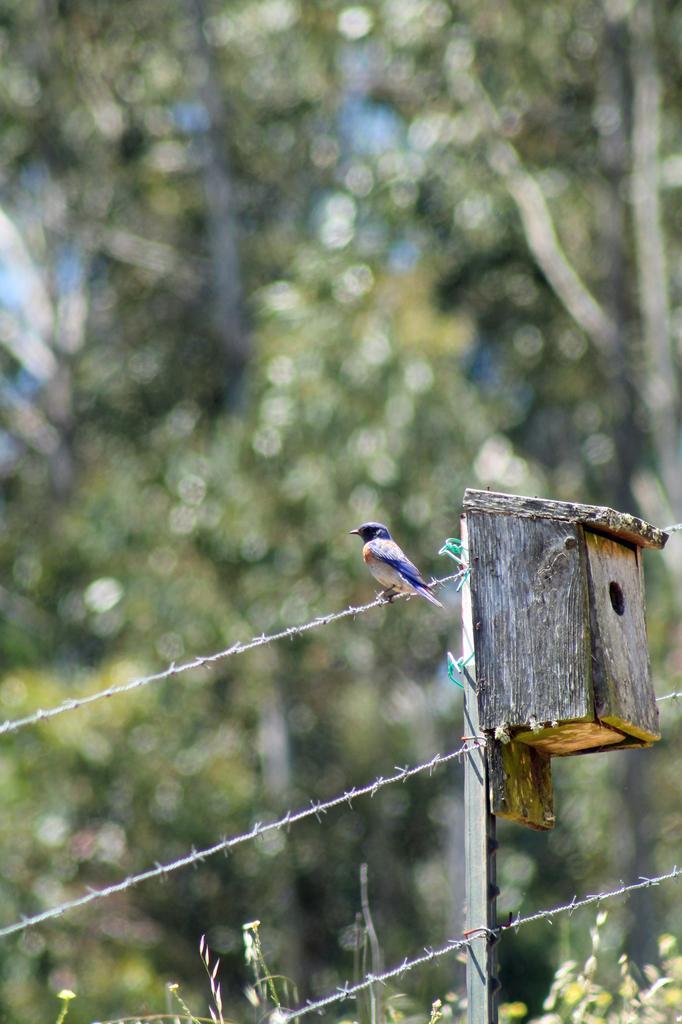Describe this image in one or two sentences. In this image there is a bird standing on the fence. Behind the bird there is a wooden box. In the background of the image there are trees. 